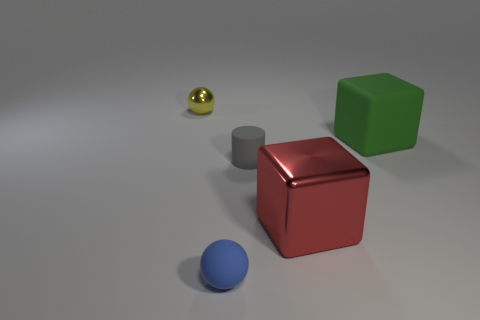What color is the thing that is behind the gray matte cylinder and on the right side of the blue ball?
Ensure brevity in your answer.  Green. How many tiny purple shiny cubes are there?
Ensure brevity in your answer.  0. Is the material of the big green block the same as the yellow thing?
Provide a succinct answer. No. There is a matte object that is to the right of the shiny thing to the right of the metallic object behind the big green object; what is its shape?
Provide a short and direct response. Cube. Is the sphere that is behind the gray cylinder made of the same material as the block that is in front of the gray rubber object?
Offer a very short reply. Yes. What is the material of the blue object?
Provide a short and direct response. Rubber. What number of other small objects have the same shape as the red metallic object?
Provide a succinct answer. 0. Are there any other things that have the same shape as the green rubber object?
Ensure brevity in your answer.  Yes. What is the color of the metallic object that is in front of the small sphere that is to the left of the tiny sphere that is on the right side of the tiny metallic sphere?
Your response must be concise. Red. How many tiny objects are shiny spheres or blue spheres?
Offer a terse response. 2. 